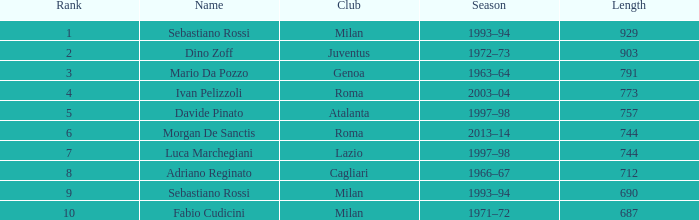What name is associated with a longer length than 903? Sebastiano Rossi. 